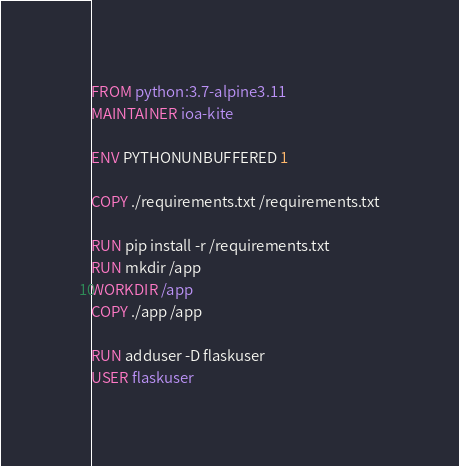<code> <loc_0><loc_0><loc_500><loc_500><_Dockerfile_>FROM python:3.7-alpine3.11
MAINTAINER ioa-kite

ENV PYTHONUNBUFFERED 1

COPY ./requirements.txt /requirements.txt

RUN pip install -r /requirements.txt
RUN mkdir /app
WORKDIR /app
COPY ./app /app

RUN adduser -D flaskuser
USER flaskuser
</code> 